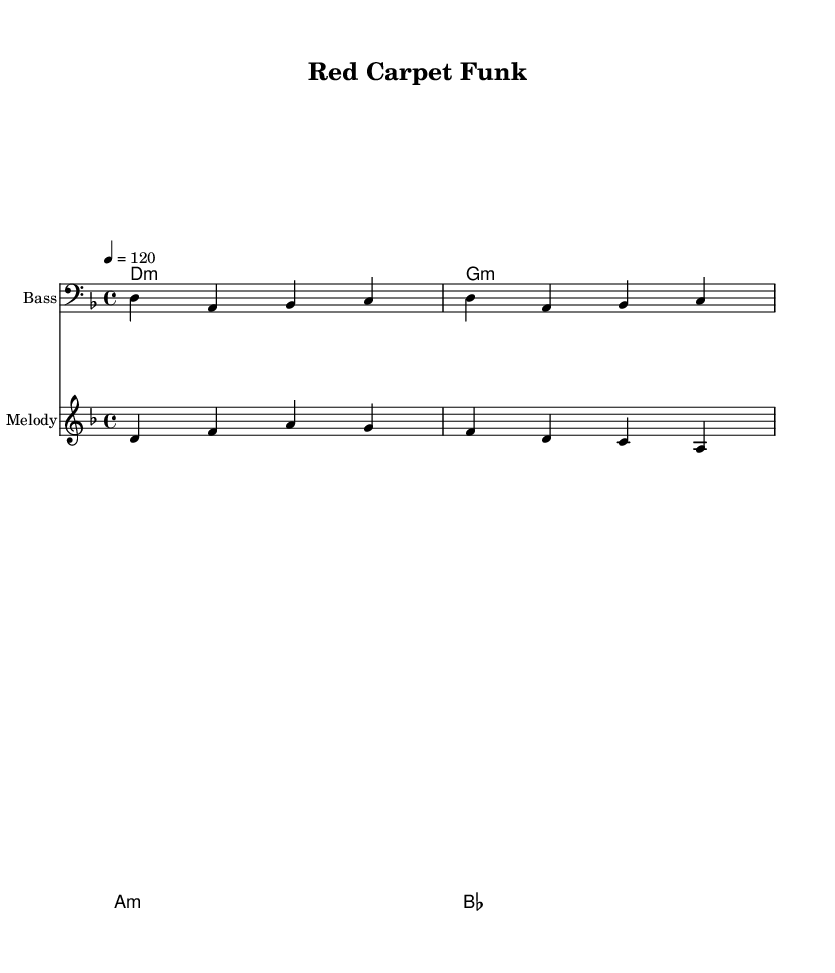What is the key signature of this music? The key signature is indicated at the beginning of the staff, where it shows one flat, which corresponds to D minor.
Answer: D minor What is the time signature of this music? The time signature is displayed at the beginning of the score, showing four beats per measure, which is indicated as 4/4.
Answer: 4/4 What is the tempo marking for the piece? The tempo marking at the beginning indicates a speed of 120 beats per minute, showing how fast the music should be played.
Answer: 120 How many measures are there in the bass line? By counting the groupings of four beats in the bass line, there are four measures present in total.
Answer: Four What type of chord is the first chord in the piece? The first chord indicated (D1:m) refers to a D minor chord, as shown in the chord names section.
Answer: D minor What is the lyrical theme of the chorus? The lyrics suggest a satirical commentary on celebrity culture with lines pointing towards activism being superficial, encapsulated in the phrase about "activism" being a "prism."
Answer: Celebrity culture What musical style does this piece belong to? The rhythmic feel, chord progressions, and overall funk pattern indicate the style as Funk, particularly reflecting elements of a modern funk revival.
Answer: Funk 